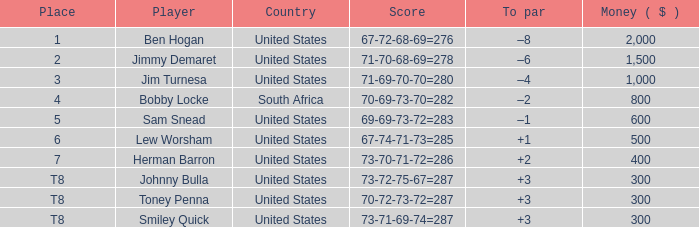Parse the table in full. {'header': ['Place', 'Player', 'Country', 'Score', 'To par', 'Money ( $ )'], 'rows': [['1', 'Ben Hogan', 'United States', '67-72-68-69=276', '–8', '2,000'], ['2', 'Jimmy Demaret', 'United States', '71-70-68-69=278', '–6', '1,500'], ['3', 'Jim Turnesa', 'United States', '71-69-70-70=280', '–4', '1,000'], ['4', 'Bobby Locke', 'South Africa', '70-69-73-70=282', '–2', '800'], ['5', 'Sam Snead', 'United States', '69-69-73-72=283', '–1', '600'], ['6', 'Lew Worsham', 'United States', '67-74-71-73=285', '+1', '500'], ['7', 'Herman Barron', 'United States', '73-70-71-72=286', '+2', '400'], ['T8', 'Johnny Bulla', 'United States', '73-72-75-67=287', '+3', '300'], ['T8', 'Toney Penna', 'United States', '70-72-73-72=287', '+3', '300'], ['T8', 'Smiley Quick', 'United States', '73-71-69-74=287', '+3', '300']]} What is the to par for a player who has a score of 73-70-71-72, totaling 286? 2.0. 